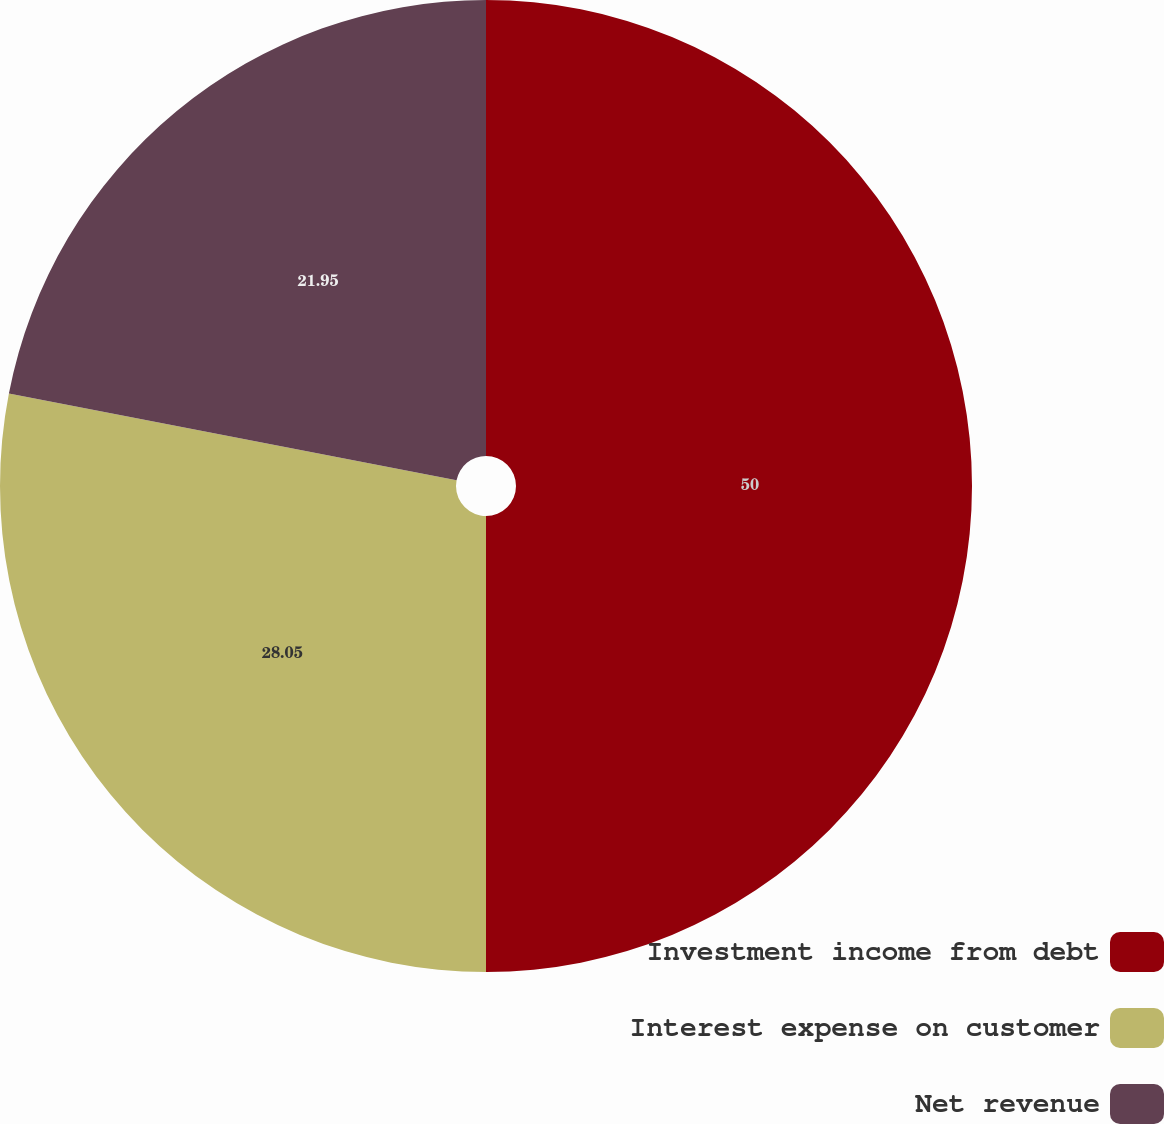Convert chart. <chart><loc_0><loc_0><loc_500><loc_500><pie_chart><fcel>Investment income from debt<fcel>Interest expense on customer<fcel>Net revenue<nl><fcel>50.0%<fcel>28.05%<fcel>21.95%<nl></chart> 